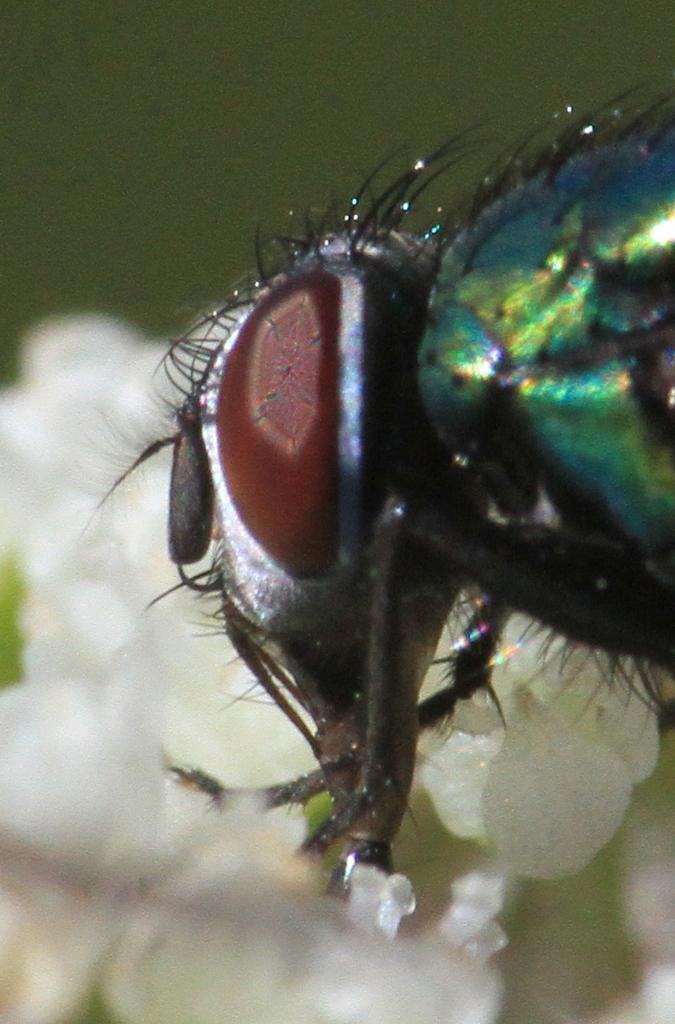What type of living organism can be seen in the image? There is an insect in the image. What other objects or elements are present in the image? There are flowers in the image. What color are the flowers? The flowers are white in color. What is the color of the background in the image? The background of the image is green in color. Where is the faucet located in the image? There is no faucet present in the image. What type of curve can be seen in the image? There is no curve visible in the image; it features an insect and white flowers against a green background. 